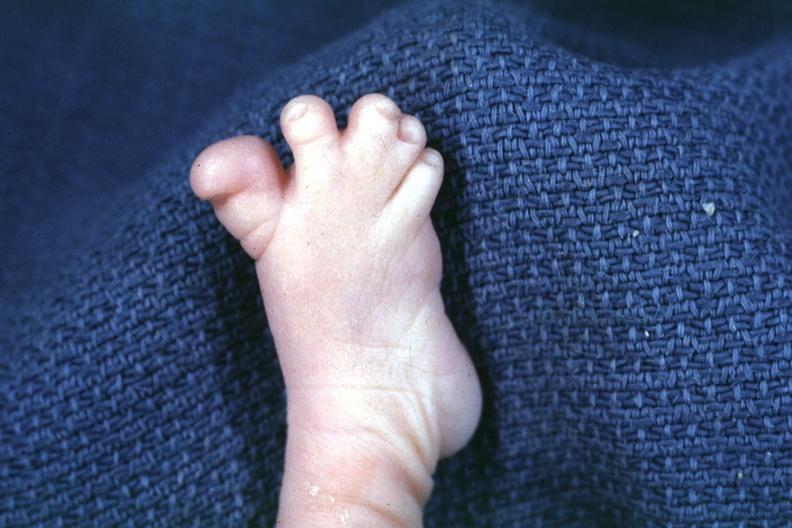s foot present?
Answer the question using a single word or phrase. Yes 